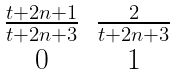<formula> <loc_0><loc_0><loc_500><loc_500>\begin{matrix} \frac { t + 2 n + 1 } { t + 2 n + 3 } & \frac { 2 } { t + 2 n + 3 } \\ 0 & 1 \end{matrix}</formula> 